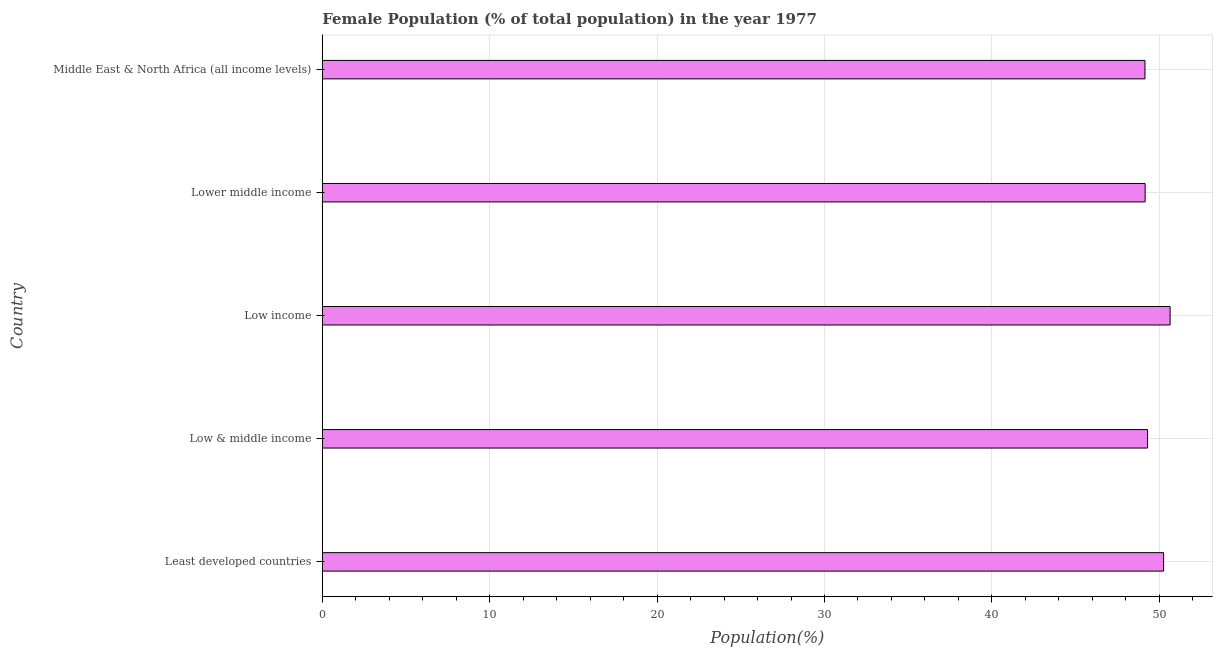Does the graph contain any zero values?
Ensure brevity in your answer.  No. Does the graph contain grids?
Provide a short and direct response. Yes. What is the title of the graph?
Give a very brief answer. Female Population (% of total population) in the year 1977. What is the label or title of the X-axis?
Your answer should be compact. Population(%). What is the female population in Least developed countries?
Offer a terse response. 50.26. Across all countries, what is the maximum female population?
Make the answer very short. 50.65. Across all countries, what is the minimum female population?
Keep it short and to the point. 49.15. In which country was the female population minimum?
Keep it short and to the point. Middle East & North Africa (all income levels). What is the sum of the female population?
Ensure brevity in your answer.  248.51. What is the difference between the female population in Low & middle income and Lower middle income?
Provide a succinct answer. 0.14. What is the average female population per country?
Keep it short and to the point. 49.7. What is the median female population?
Offer a very short reply. 49.3. In how many countries, is the female population greater than 30 %?
Your answer should be compact. 5. Is the female population in Least developed countries less than that in Low income?
Give a very brief answer. Yes. What is the difference between the highest and the second highest female population?
Your response must be concise. 0.39. Is the sum of the female population in Low & middle income and Middle East & North Africa (all income levels) greater than the maximum female population across all countries?
Offer a terse response. Yes. How many countries are there in the graph?
Offer a terse response. 5. Are the values on the major ticks of X-axis written in scientific E-notation?
Keep it short and to the point. No. What is the Population(%) in Least developed countries?
Your answer should be very brief. 50.26. What is the Population(%) of Low & middle income?
Your answer should be compact. 49.3. What is the Population(%) of Low income?
Provide a succinct answer. 50.65. What is the Population(%) of Lower middle income?
Provide a succinct answer. 49.16. What is the Population(%) in Middle East & North Africa (all income levels)?
Keep it short and to the point. 49.15. What is the difference between the Population(%) in Least developed countries and Low & middle income?
Provide a succinct answer. 0.96. What is the difference between the Population(%) in Least developed countries and Low income?
Your answer should be compact. -0.39. What is the difference between the Population(%) in Least developed countries and Lower middle income?
Ensure brevity in your answer.  1.1. What is the difference between the Population(%) in Least developed countries and Middle East & North Africa (all income levels)?
Provide a succinct answer. 1.11. What is the difference between the Population(%) in Low & middle income and Low income?
Make the answer very short. -1.35. What is the difference between the Population(%) in Low & middle income and Lower middle income?
Ensure brevity in your answer.  0.14. What is the difference between the Population(%) in Low & middle income and Middle East & North Africa (all income levels)?
Make the answer very short. 0.15. What is the difference between the Population(%) in Low income and Lower middle income?
Keep it short and to the point. 1.49. What is the difference between the Population(%) in Low income and Middle East & North Africa (all income levels)?
Your response must be concise. 1.5. What is the difference between the Population(%) in Lower middle income and Middle East & North Africa (all income levels)?
Your answer should be compact. 0.01. What is the ratio of the Population(%) in Least developed countries to that in Low & middle income?
Offer a terse response. 1.02. What is the ratio of the Population(%) in Low & middle income to that in Low income?
Offer a terse response. 0.97. What is the ratio of the Population(%) in Low & middle income to that in Middle East & North Africa (all income levels)?
Ensure brevity in your answer.  1. What is the ratio of the Population(%) in Low income to that in Lower middle income?
Ensure brevity in your answer.  1.03. What is the ratio of the Population(%) in Low income to that in Middle East & North Africa (all income levels)?
Your answer should be compact. 1.03. 